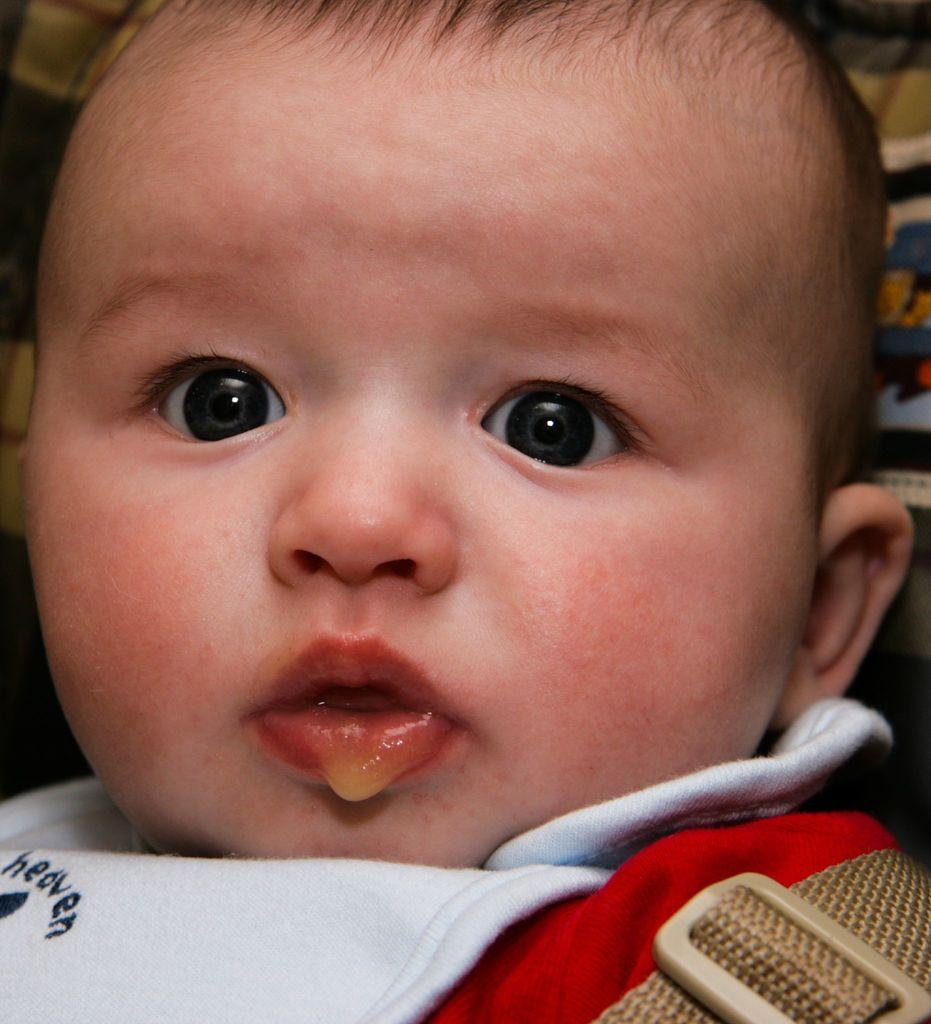What is the main subject of the image? There is a baby in the image. What type of tail does the baby have in the image? There is no tail present on the baby in the image. How many pigs are visible in the image? There are no pigs present in the image; it only features a baby. 